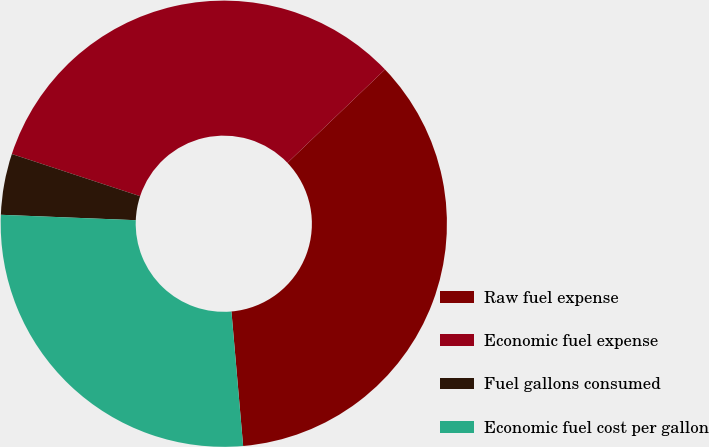<chart> <loc_0><loc_0><loc_500><loc_500><pie_chart><fcel>Raw fuel expense<fcel>Economic fuel expense<fcel>Fuel gallons consumed<fcel>Economic fuel cost per gallon<nl><fcel>35.77%<fcel>32.79%<fcel>4.42%<fcel>27.02%<nl></chart> 